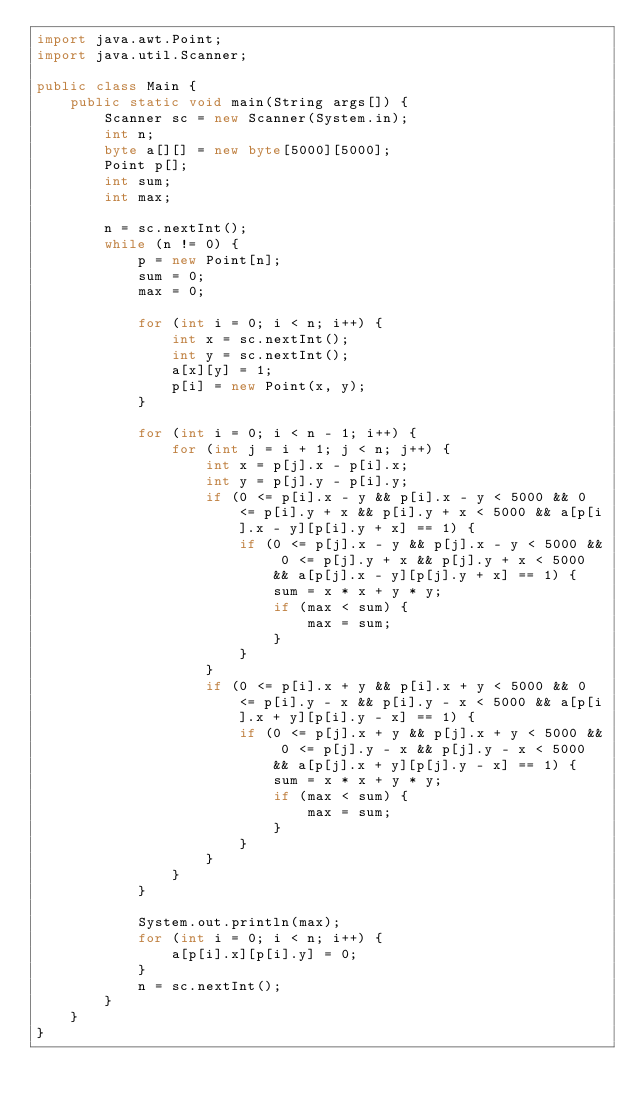Convert code to text. <code><loc_0><loc_0><loc_500><loc_500><_Java_>import java.awt.Point;
import java.util.Scanner;

public class Main {
	public static void main(String args[]) {
		Scanner sc = new Scanner(System.in);
		int n;
		byte a[][] = new byte[5000][5000];
		Point p[];
		int sum;
		int max;

		n = sc.nextInt();
		while (n != 0) {
			p = new Point[n];
			sum = 0;
			max = 0;

			for (int i = 0; i < n; i++) {
				int x = sc.nextInt();
				int y = sc.nextInt();
				a[x][y] = 1;
				p[i] = new Point(x, y);
			}

			for (int i = 0; i < n - 1; i++) {
				for (int j = i + 1; j < n; j++) {
					int x = p[j].x - p[i].x;
					int y = p[j].y - p[i].y;
					if (0 <= p[i].x - y && p[i].x - y < 5000 && 0 <= p[i].y + x && p[i].y + x < 5000 && a[p[i].x - y][p[i].y + x] == 1) {
						if (0 <= p[j].x - y && p[j].x - y < 5000 && 0 <= p[j].y + x && p[j].y + x < 5000 && a[p[j].x - y][p[j].y + x] == 1) {
							sum = x * x + y * y;
							if (max < sum) {
								max = sum;
							}
						}
					}
					if (0 <= p[i].x + y && p[i].x + y < 5000 && 0 <= p[i].y - x && p[i].y - x < 5000 && a[p[i].x + y][p[i].y - x] == 1) {
						if (0 <= p[j].x + y && p[j].x + y < 5000 && 0 <= p[j].y - x && p[j].y - x < 5000 && a[p[j].x + y][p[j].y - x] == 1) {
							sum = x * x + y * y;
							if (max < sum) {
								max = sum;
							}
						}
					}
				}
			}
			
			System.out.println(max);
			for (int i = 0; i < n; i++) {
				a[p[i].x][p[i].y] = 0;
			}
			n = sc.nextInt();
		}
	}
}</code> 